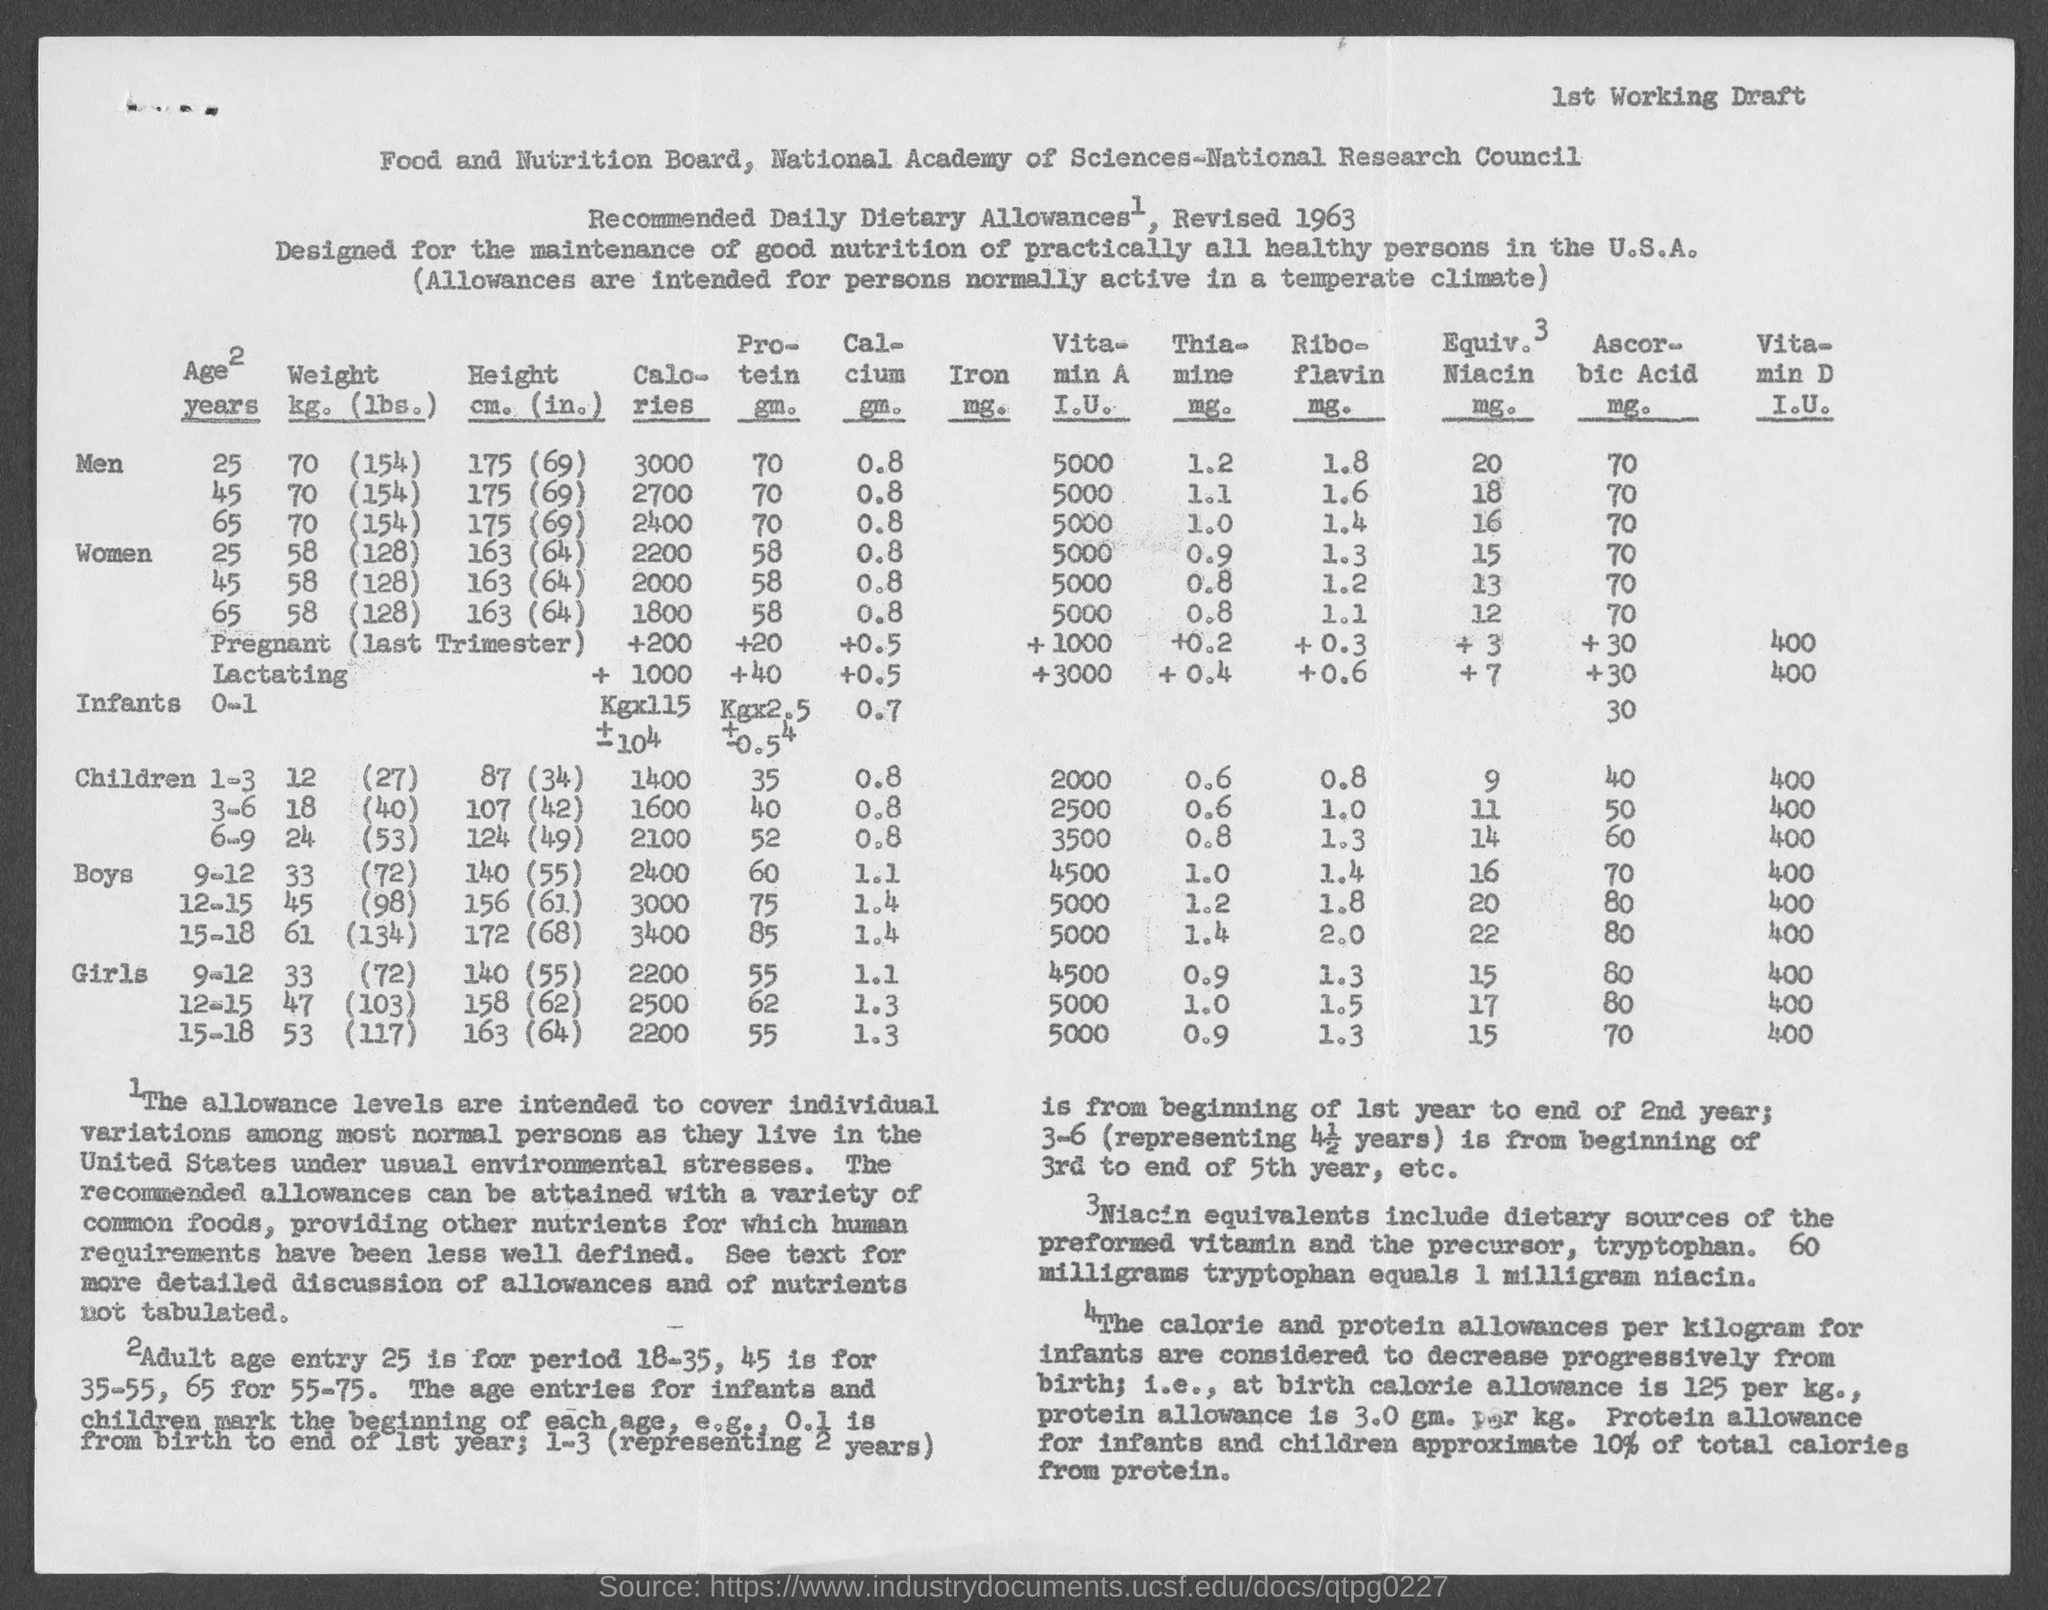What is written on right top corner of the page?
Keep it short and to the point. 1st Working Draft. What is the heading of the document?
Make the answer very short. Food and Nutrition Board, National Academy of Sciences-National Research Council. Revised "Recommended Daily Dietary Allowances" of which year is given?
Keep it short and to the point. 1963. What is the "Adult age entry" for period 18-35?
Provide a succinct answer. 25. What is the "Adult age entry" for period 35-55?
Your answer should be very brief. 45. What is the "Adult age entry" for period 55-75?
Your response must be concise. 65. What quantity of "tryptophan equals 1 milligram niacin?
Provide a short and direct response. 60 milligrams. How much is "calorie allowance" AT BIRTH?
Ensure brevity in your answer.  125 per kg. How much is "protein allowance" AT BIRTH?
Your answer should be very brief. 3.0 gm. per Kg. "Protein allowance for infants and children approximate" what "percentage of total calories from protein"?
Ensure brevity in your answer.  10%. 